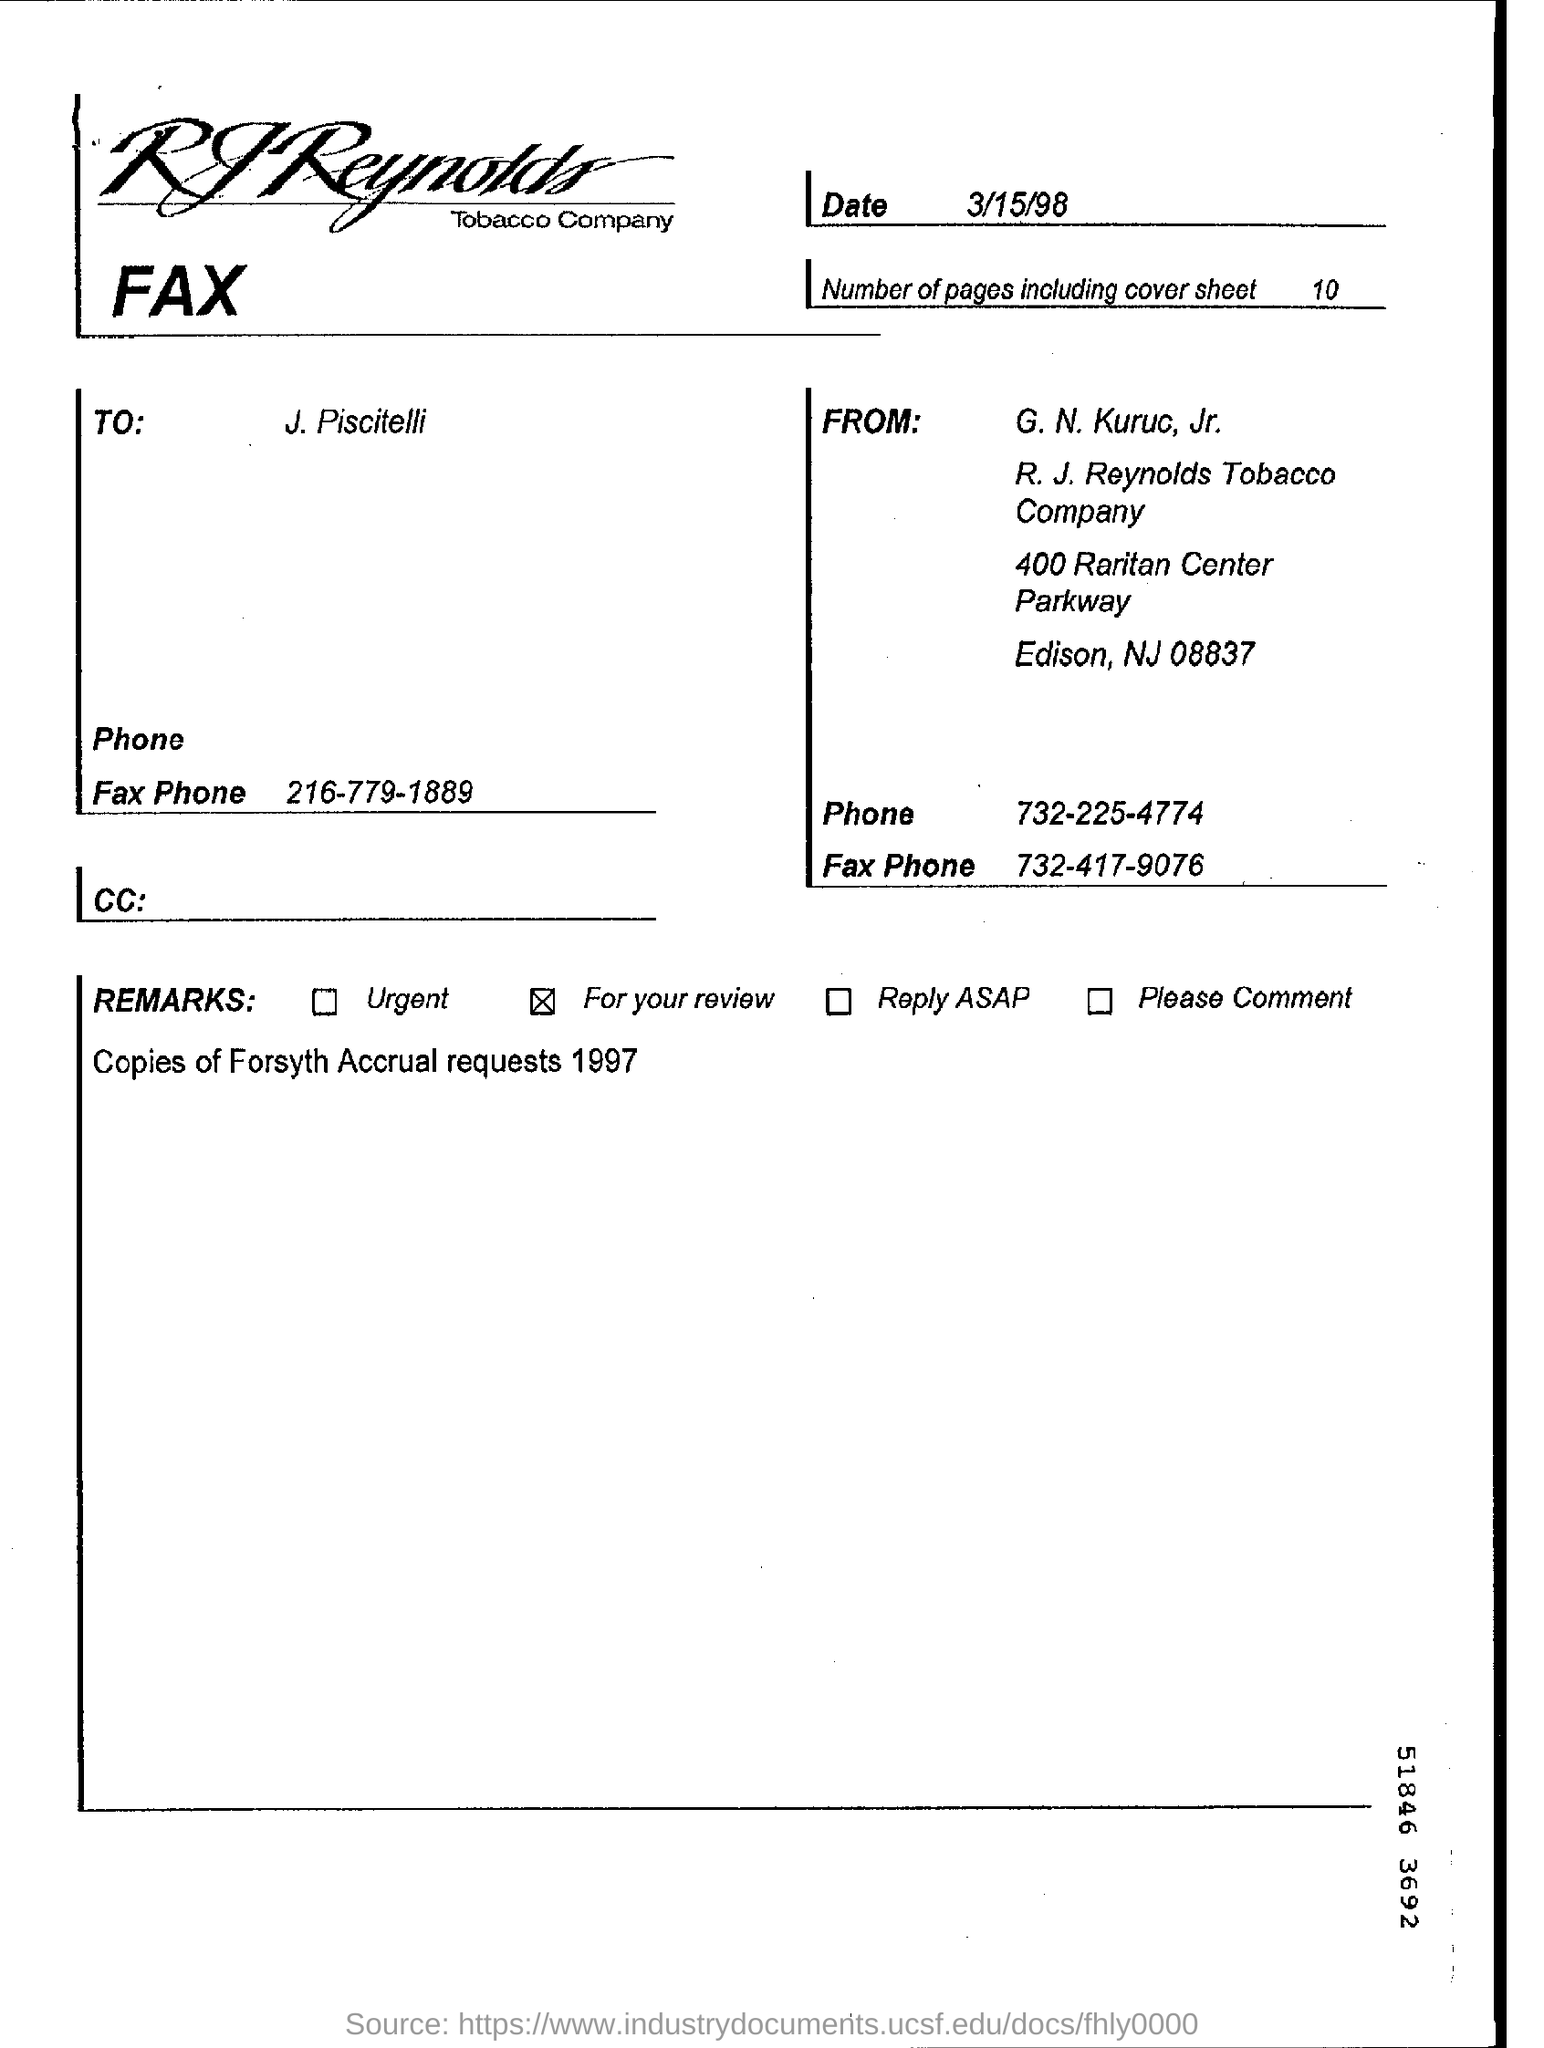What is the zip code mentioned in the from address?
Provide a short and direct response. 08837. How many number of sheets are faxed?
Provide a succinct answer. 10. When is the document faxed?
Provide a succinct answer. 3/15/98. Who faxed the document?
Make the answer very short. G. N. Kuruc, Jr. In"REMARKS" which field is selected?
Your response must be concise. For your review. 